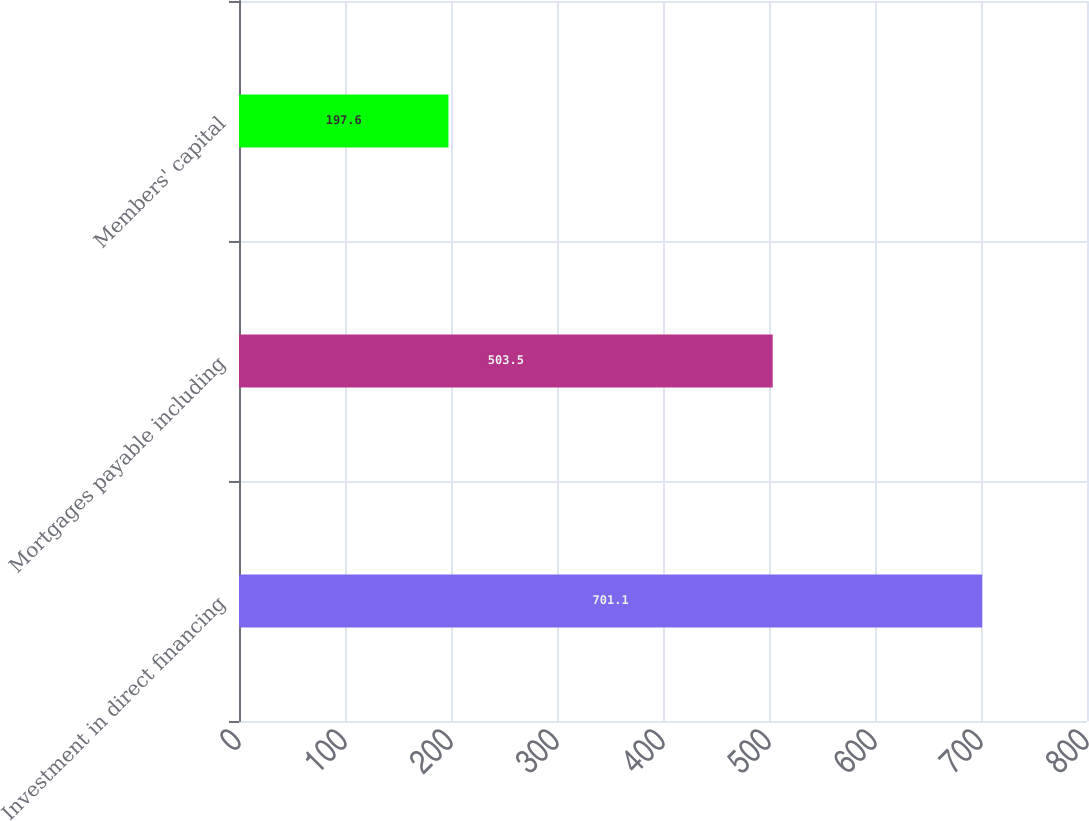Convert chart to OTSL. <chart><loc_0><loc_0><loc_500><loc_500><bar_chart><fcel>Investment in direct financing<fcel>Mortgages payable including<fcel>Members' capital<nl><fcel>701.1<fcel>503.5<fcel>197.6<nl></chart> 